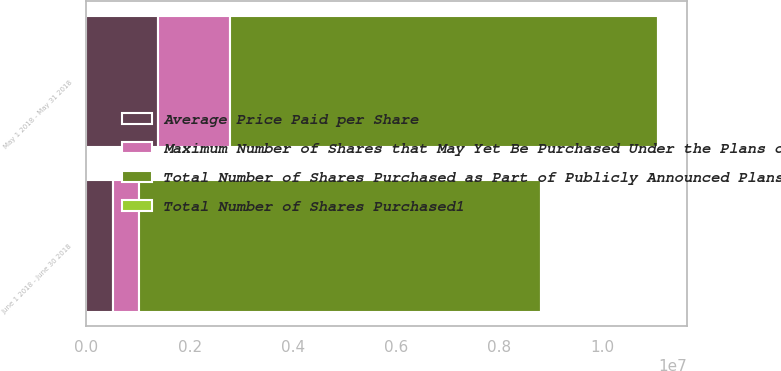<chart> <loc_0><loc_0><loc_500><loc_500><stacked_bar_chart><ecel><fcel>May 1 2018 - May 31 2018<fcel>June 1 2018 - June 30 2018<nl><fcel>Average Price Paid per Share<fcel>1.38719e+06<fcel>509269<nl><fcel>Total Number of Shares Purchased1<fcel>115.73<fcel>118.04<nl><fcel>Maximum Number of Shares that May Yet Be Purchased Under the Plans or Programs2<fcel>1.38692e+06<fcel>509200<nl><fcel>Total Number of Shares Purchased as Part of Publicly Announced Plans or Programs2<fcel>8.30081e+06<fcel>7.79161e+06<nl></chart> 